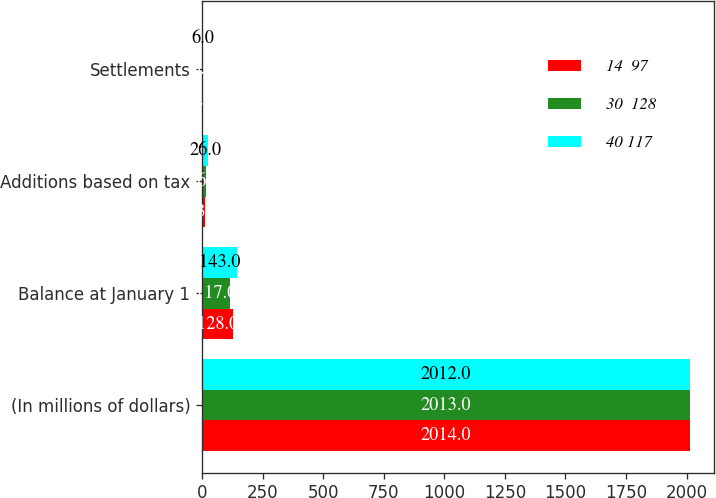Convert chart to OTSL. <chart><loc_0><loc_0><loc_500><loc_500><stacked_bar_chart><ecel><fcel>(In millions of dollars)<fcel>Balance at January 1<fcel>Additions based on tax<fcel>Settlements<nl><fcel>14  97<fcel>2014<fcel>128<fcel>13<fcel>4<nl><fcel>30  128<fcel>2013<fcel>117<fcel>16<fcel>3<nl><fcel>40 117<fcel>2012<fcel>143<fcel>26<fcel>6<nl></chart> 